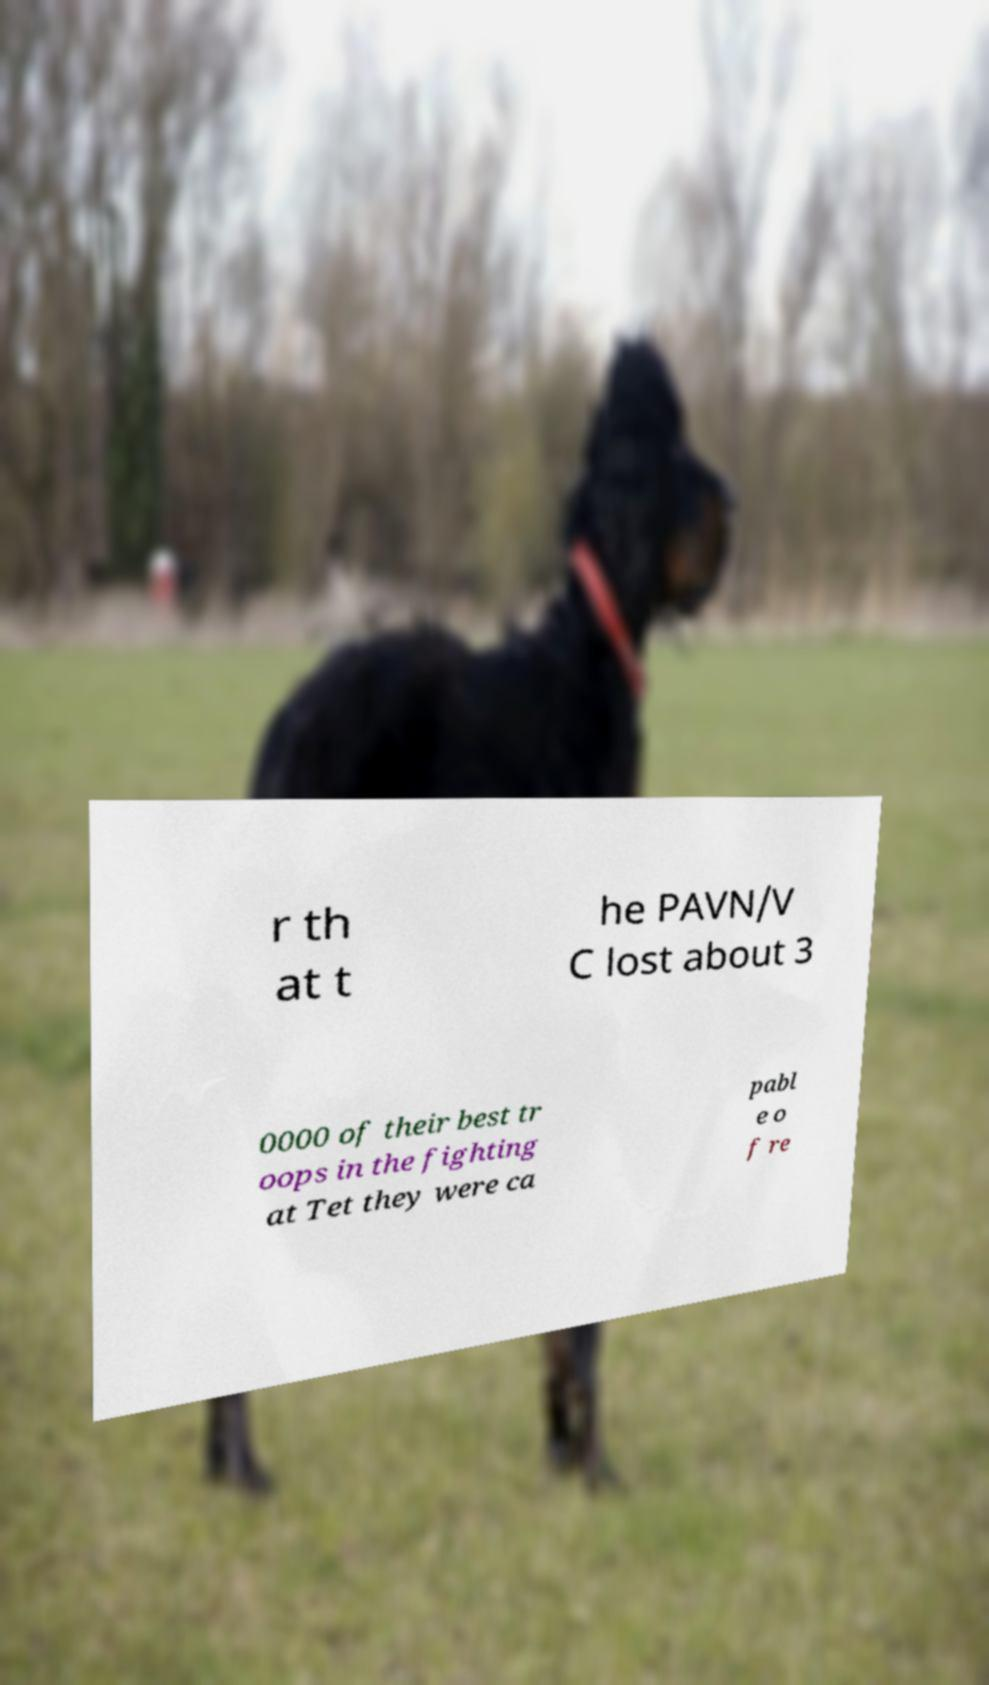Please identify and transcribe the text found in this image. r th at t he PAVN/V C lost about 3 0000 of their best tr oops in the fighting at Tet they were ca pabl e o f re 